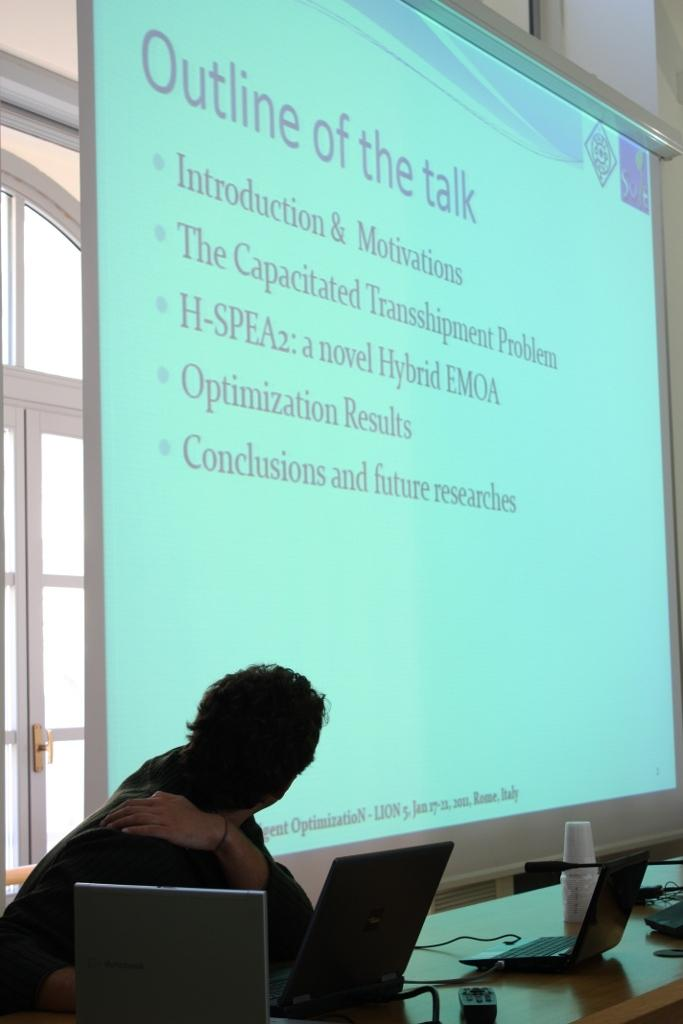<image>
Provide a brief description of the given image. a man sitting in front of a huge presentation screen titled 'outline of the talk' on it 